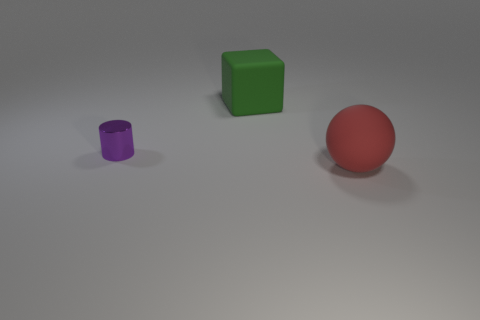Add 1 big cyan matte cylinders. How many objects exist? 4 Subtract all cylinders. How many objects are left? 2 Subtract all small purple spheres. Subtract all green matte cubes. How many objects are left? 2 Add 3 large red rubber things. How many large red rubber things are left? 4 Add 2 large cyan metallic objects. How many large cyan metallic objects exist? 2 Subtract 0 yellow cubes. How many objects are left? 3 